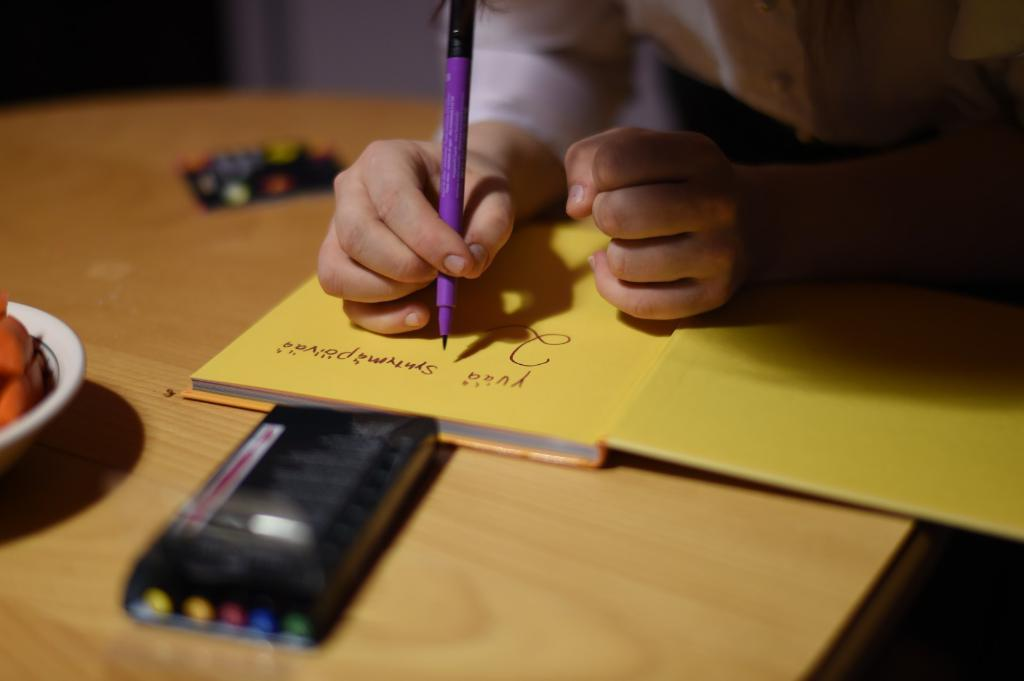What is the person in the image holding? The person is holding a pen in the image. What can be seen besides the person holding the pen? There is a book and a bowl in the image. What else is present on the table in the image? There are other unspecified things on the table in the image. How many cattle are visible in the image? There are no cattle present in the image. What type of collar is the person wearing in the image? The person in the image is not wearing a collar; they are holding a pen. 